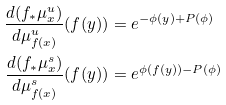<formula> <loc_0><loc_0><loc_500><loc_500>\frac { d ( f _ { * } \mu ^ { u } _ { x } ) } { d \mu ^ { u } _ { f ( x ) } } ( f ( y ) ) & = e ^ { - \phi ( y ) + P ( \phi ) } \\ \frac { d ( f _ { * } \mu ^ { s } _ { x } ) } { d \mu ^ { s } _ { f ( x ) } } ( f ( y ) ) & = e ^ { \phi ( f ( y ) ) - P ( \phi ) }</formula> 